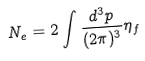<formula> <loc_0><loc_0><loc_500><loc_500>N _ { e } = 2 \int \frac { d ^ { 3 } p } { ( 2 \pi ) ^ { 3 } } \eta _ { f }</formula> 